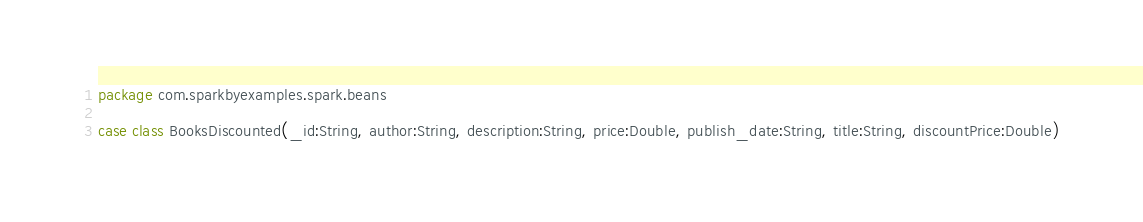<code> <loc_0><loc_0><loc_500><loc_500><_Scala_>package com.sparkbyexamples.spark.beans

case class BooksDiscounted(_id:String, author:String, description:String, price:Double, publish_date:String, title:String, discountPrice:Double)

</code> 